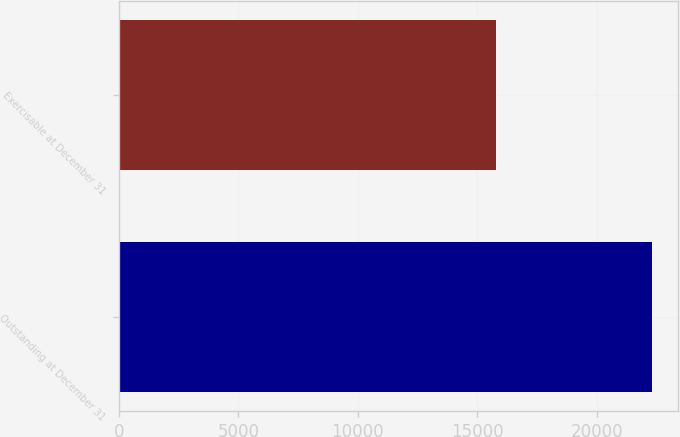Convert chart to OTSL. <chart><loc_0><loc_0><loc_500><loc_500><bar_chart><fcel>Outstanding at December 31<fcel>Exercisable at December 31<nl><fcel>22309<fcel>15773<nl></chart> 